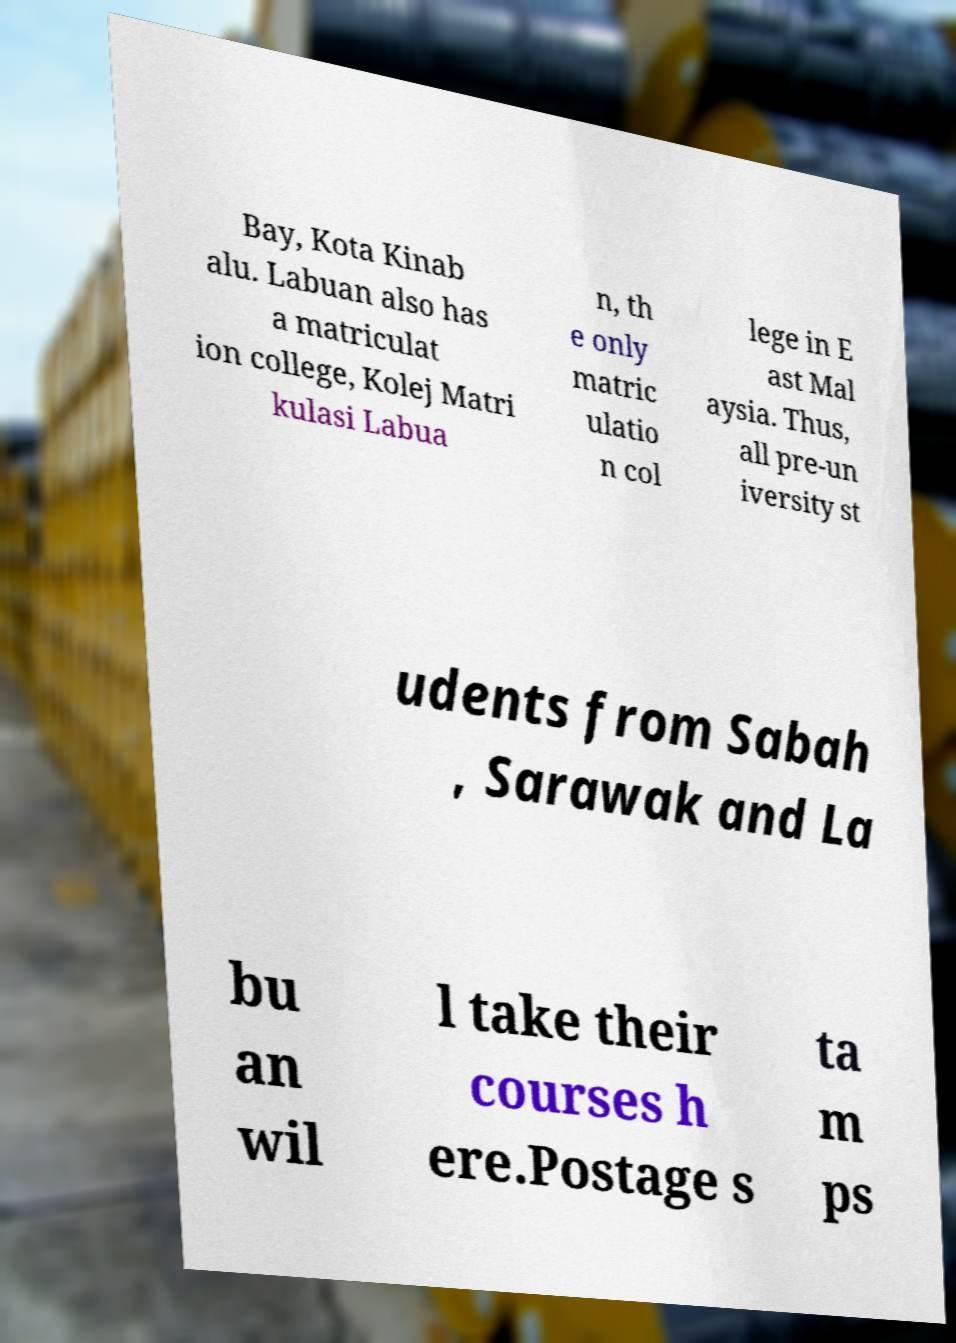What messages or text are displayed in this image? I need them in a readable, typed format. Bay, Kota Kinab alu. Labuan also has a matriculat ion college, Kolej Matri kulasi Labua n, th e only matric ulatio n col lege in E ast Mal aysia. Thus, all pre-un iversity st udents from Sabah , Sarawak and La bu an wil l take their courses h ere.Postage s ta m ps 